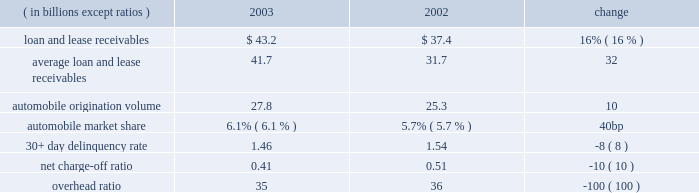Business-related metrics as of or for the year ended december 31 .
Crb is the no .
1 bank in the new york tri-state area and a top five bank in texas ( both ranked by retail deposits ) , providing payment , liquidity , investment , insurance and credit products and services to three primary customer segments : small busi- ness , affluent and retail .
Within these segments , crb serves 326000 small businesses , 433000 affluent consumers and 2.6 million mass-market consumers .
Crb 2019s continued focus on expanding customer relationships resulted in a 14% ( 14 % ) increase in core deposits ( for this purpose , core deposits are total deposits less time deposits ) from december 31 , 2002 , and a 77% ( 77 % ) increase in the cross-sell of chase credit products over 2002 .
In 2003 , mortgage and home equity originations through crb 2019s distribution channels were $ 3.4 billion and $ 4.7 billion , respectively .
Branch-originated credit cards totaled 77000 , contributing to 23% ( 23 % ) of crb customers holding chase credit cards .
Crb is compensated by cfs 2019s credit businesses for the home finance and credit card loans it origi- nates and does not retain these balances .
Chase regional banking while crb continues to position itself for growth , decreased deposit spreads related to the low-rate environment and increased credit costs resulted in an 80% ( 80 % ) decline in crb operating earnings from 2002 .
This decrease was partly offset by an 8% ( 8 % ) increase in total average deposits .
Operating revenue of $ 2.6 billion decreased by 9% ( 9 % ) compared with 2002 .
Net interest income declined by 11% ( 11 % ) to $ 1.7 billion , primarily attributable to the lower interest rate environment .
Noninterest revenue decreased 6% ( 6 % ) to $ 927 million due to lower deposit service fees , decreased debit card fees and one-time gains in 2002 .
Crb 2019s revenue does not include funding profits earned on its deposit base ; these amounts are included in the results of global treasury .
Operating expense of $ 2.4 billion increased by 7% ( 7 % ) from 2002 .
The increase was primarily due to investments in technology within the branch network ; also contributing were higher compensation expenses related to increased staff levels and higher severance costs as a result of continued restructuring .
This increase in operating caf is the largest u.s .
Bank originator of automobile loans and leases , with more than 2.9 million accounts .
In 2003 , caf had a record number of automobile loan and lease originations , growing by 10% ( 10 % ) over 2002 to $ 27.8 billion .
Loan and lease receivables of $ 43.2 billion at december 31 , 2003 , were 16% ( 16 % ) higher than at the prior year-end .
Despite a challenging operating environment reflecting slightly declining new car sales in 2003 and increased competition , caf 2019s market share among automobile finance companies improved to 6.1% ( 6.1 % ) in 2003 from 5.7% ( 5.7 % ) in 2002 .
The increase in market share was the result of strong organic growth and an origination strategy that allies the business with manufac- turers and dealers .
Caf 2019s relationships with several major car manufacturers contributed to 2003 growth , as did caf 2019s dealer relationships , which increased from approximately 12700 dealers in 2002 to approximately 13700 dealers in 2003 .
In 2003 , operating earnings were $ 205 million , 23% ( 23 % ) higher compared with 2002 .
The increase in earnings was driven by continued revenue growth and improved operating efficiency .
In 2003 , caf 2019s operating revenue grew by 23% ( 23 % ) to $ 842 million .
Net interest income grew by 33% ( 33 % ) compared with 2002 .
The increase was driven by strong operating performance due to higher average loans and leases outstanding , reflecting continued strong origination volume and lower funding costs .
Operating expense of $ 292 million increased by 18% ( 18 % ) compared with 2002 .
The increase in expenses was driven by higher average chase auto finance loans outstanding , higher origination volume and higher perform- ance-based incentives .
Caf 2019s overhead ratio improved from 36% ( 36 % ) in 2002 to 35% ( 35 % ) in 2003 , as a result of strong revenue growth , con- tinued productivity gains and disciplined expense management .
Credit costs increased 18% ( 18 % ) to $ 205 million , primarily reflecting a 32% ( 32 % ) increase in average loan and lease receivables .
Credit quality continued to be strong relative to 2002 , as evidenced by a lower net charge-off ratio and 30+ day delinquency rate .
Caf also comprises chase education finance , a top provider of government-guaranteed and private loans for higher education .
Loans are provided through a joint venture with sallie mae , a government-sponsored enterprise and the leader in funding and servicing education loans .
Chase education finance 2019s origination volume totaled $ 2.7 billion , an increase of 4% ( 4 % ) from last year .
Management 2019s discussion and analysis j.p .
Morgan chase & co .
42 j.p .
Morgan chase & co .
/ 2003 annual report .
What was the ratio of the average loan and lease receivables to the automobile origination volume? 
Computations: (41.7 / 27.8)
Answer: 1.5. Business-related metrics as of or for the year ended december 31 .
Crb is the no .
1 bank in the new york tri-state area and a top five bank in texas ( both ranked by retail deposits ) , providing payment , liquidity , investment , insurance and credit products and services to three primary customer segments : small busi- ness , affluent and retail .
Within these segments , crb serves 326000 small businesses , 433000 affluent consumers and 2.6 million mass-market consumers .
Crb 2019s continued focus on expanding customer relationships resulted in a 14% ( 14 % ) increase in core deposits ( for this purpose , core deposits are total deposits less time deposits ) from december 31 , 2002 , and a 77% ( 77 % ) increase in the cross-sell of chase credit products over 2002 .
In 2003 , mortgage and home equity originations through crb 2019s distribution channels were $ 3.4 billion and $ 4.7 billion , respectively .
Branch-originated credit cards totaled 77000 , contributing to 23% ( 23 % ) of crb customers holding chase credit cards .
Crb is compensated by cfs 2019s credit businesses for the home finance and credit card loans it origi- nates and does not retain these balances .
Chase regional banking while crb continues to position itself for growth , decreased deposit spreads related to the low-rate environment and increased credit costs resulted in an 80% ( 80 % ) decline in crb operating earnings from 2002 .
This decrease was partly offset by an 8% ( 8 % ) increase in total average deposits .
Operating revenue of $ 2.6 billion decreased by 9% ( 9 % ) compared with 2002 .
Net interest income declined by 11% ( 11 % ) to $ 1.7 billion , primarily attributable to the lower interest rate environment .
Noninterest revenue decreased 6% ( 6 % ) to $ 927 million due to lower deposit service fees , decreased debit card fees and one-time gains in 2002 .
Crb 2019s revenue does not include funding profits earned on its deposit base ; these amounts are included in the results of global treasury .
Operating expense of $ 2.4 billion increased by 7% ( 7 % ) from 2002 .
The increase was primarily due to investments in technology within the branch network ; also contributing were higher compensation expenses related to increased staff levels and higher severance costs as a result of continued restructuring .
This increase in operating caf is the largest u.s .
Bank originator of automobile loans and leases , with more than 2.9 million accounts .
In 2003 , caf had a record number of automobile loan and lease originations , growing by 10% ( 10 % ) over 2002 to $ 27.8 billion .
Loan and lease receivables of $ 43.2 billion at december 31 , 2003 , were 16% ( 16 % ) higher than at the prior year-end .
Despite a challenging operating environment reflecting slightly declining new car sales in 2003 and increased competition , caf 2019s market share among automobile finance companies improved to 6.1% ( 6.1 % ) in 2003 from 5.7% ( 5.7 % ) in 2002 .
The increase in market share was the result of strong organic growth and an origination strategy that allies the business with manufac- turers and dealers .
Caf 2019s relationships with several major car manufacturers contributed to 2003 growth , as did caf 2019s dealer relationships , which increased from approximately 12700 dealers in 2002 to approximately 13700 dealers in 2003 .
In 2003 , operating earnings were $ 205 million , 23% ( 23 % ) higher compared with 2002 .
The increase in earnings was driven by continued revenue growth and improved operating efficiency .
In 2003 , caf 2019s operating revenue grew by 23% ( 23 % ) to $ 842 million .
Net interest income grew by 33% ( 33 % ) compared with 2002 .
The increase was driven by strong operating performance due to higher average loans and leases outstanding , reflecting continued strong origination volume and lower funding costs .
Operating expense of $ 292 million increased by 18% ( 18 % ) compared with 2002 .
The increase in expenses was driven by higher average chase auto finance loans outstanding , higher origination volume and higher perform- ance-based incentives .
Caf 2019s overhead ratio improved from 36% ( 36 % ) in 2002 to 35% ( 35 % ) in 2003 , as a result of strong revenue growth , con- tinued productivity gains and disciplined expense management .
Credit costs increased 18% ( 18 % ) to $ 205 million , primarily reflecting a 32% ( 32 % ) increase in average loan and lease receivables .
Credit quality continued to be strong relative to 2002 , as evidenced by a lower net charge-off ratio and 30+ day delinquency rate .
Caf also comprises chase education finance , a top provider of government-guaranteed and private loans for higher education .
Loans are provided through a joint venture with sallie mae , a government-sponsored enterprise and the leader in funding and servicing education loans .
Chase education finance 2019s origination volume totaled $ 2.7 billion , an increase of 4% ( 4 % ) from last year .
Management 2019s discussion and analysis j.p .
Morgan chase & co .
42 j.p .
Morgan chase & co .
/ 2003 annual report .
What was the operating revenue in 2002? 
Computations: (205 * (100 - 23%))
Answer: 20452.85. Business-related metrics as of or for the year ended december 31 .
Crb is the no .
1 bank in the new york tri-state area and a top five bank in texas ( both ranked by retail deposits ) , providing payment , liquidity , investment , insurance and credit products and services to three primary customer segments : small busi- ness , affluent and retail .
Within these segments , crb serves 326000 small businesses , 433000 affluent consumers and 2.6 million mass-market consumers .
Crb 2019s continued focus on expanding customer relationships resulted in a 14% ( 14 % ) increase in core deposits ( for this purpose , core deposits are total deposits less time deposits ) from december 31 , 2002 , and a 77% ( 77 % ) increase in the cross-sell of chase credit products over 2002 .
In 2003 , mortgage and home equity originations through crb 2019s distribution channels were $ 3.4 billion and $ 4.7 billion , respectively .
Branch-originated credit cards totaled 77000 , contributing to 23% ( 23 % ) of crb customers holding chase credit cards .
Crb is compensated by cfs 2019s credit businesses for the home finance and credit card loans it origi- nates and does not retain these balances .
Chase regional banking while crb continues to position itself for growth , decreased deposit spreads related to the low-rate environment and increased credit costs resulted in an 80% ( 80 % ) decline in crb operating earnings from 2002 .
This decrease was partly offset by an 8% ( 8 % ) increase in total average deposits .
Operating revenue of $ 2.6 billion decreased by 9% ( 9 % ) compared with 2002 .
Net interest income declined by 11% ( 11 % ) to $ 1.7 billion , primarily attributable to the lower interest rate environment .
Noninterest revenue decreased 6% ( 6 % ) to $ 927 million due to lower deposit service fees , decreased debit card fees and one-time gains in 2002 .
Crb 2019s revenue does not include funding profits earned on its deposit base ; these amounts are included in the results of global treasury .
Operating expense of $ 2.4 billion increased by 7% ( 7 % ) from 2002 .
The increase was primarily due to investments in technology within the branch network ; also contributing were higher compensation expenses related to increased staff levels and higher severance costs as a result of continued restructuring .
This increase in operating caf is the largest u.s .
Bank originator of automobile loans and leases , with more than 2.9 million accounts .
In 2003 , caf had a record number of automobile loan and lease originations , growing by 10% ( 10 % ) over 2002 to $ 27.8 billion .
Loan and lease receivables of $ 43.2 billion at december 31 , 2003 , were 16% ( 16 % ) higher than at the prior year-end .
Despite a challenging operating environment reflecting slightly declining new car sales in 2003 and increased competition , caf 2019s market share among automobile finance companies improved to 6.1% ( 6.1 % ) in 2003 from 5.7% ( 5.7 % ) in 2002 .
The increase in market share was the result of strong organic growth and an origination strategy that allies the business with manufac- turers and dealers .
Caf 2019s relationships with several major car manufacturers contributed to 2003 growth , as did caf 2019s dealer relationships , which increased from approximately 12700 dealers in 2002 to approximately 13700 dealers in 2003 .
In 2003 , operating earnings were $ 205 million , 23% ( 23 % ) higher compared with 2002 .
The increase in earnings was driven by continued revenue growth and improved operating efficiency .
In 2003 , caf 2019s operating revenue grew by 23% ( 23 % ) to $ 842 million .
Net interest income grew by 33% ( 33 % ) compared with 2002 .
The increase was driven by strong operating performance due to higher average loans and leases outstanding , reflecting continued strong origination volume and lower funding costs .
Operating expense of $ 292 million increased by 18% ( 18 % ) compared with 2002 .
The increase in expenses was driven by higher average chase auto finance loans outstanding , higher origination volume and higher perform- ance-based incentives .
Caf 2019s overhead ratio improved from 36% ( 36 % ) in 2002 to 35% ( 35 % ) in 2003 , as a result of strong revenue growth , con- tinued productivity gains and disciplined expense management .
Credit costs increased 18% ( 18 % ) to $ 205 million , primarily reflecting a 32% ( 32 % ) increase in average loan and lease receivables .
Credit quality continued to be strong relative to 2002 , as evidenced by a lower net charge-off ratio and 30+ day delinquency rate .
Caf also comprises chase education finance , a top provider of government-guaranteed and private loans for higher education .
Loans are provided through a joint venture with sallie mae , a government-sponsored enterprise and the leader in funding and servicing education loans .
Chase education finance 2019s origination volume totaled $ 2.7 billion , an increase of 4% ( 4 % ) from last year .
Management 2019s discussion and analysis j.p .
Morgan chase & co .
42 j.p .
Morgan chase & co .
/ 2003 annual report .
What was the 2003 improvement in the 30+ day delinquency rate , ( us$ b ) ? 
Computations: ((8 / 100) * 1.54)
Answer: 0.1232. Business-related metrics as of or for the year ended december 31 .
Crb is the no .
1 bank in the new york tri-state area and a top five bank in texas ( both ranked by retail deposits ) , providing payment , liquidity , investment , insurance and credit products and services to three primary customer segments : small busi- ness , affluent and retail .
Within these segments , crb serves 326000 small businesses , 433000 affluent consumers and 2.6 million mass-market consumers .
Crb 2019s continued focus on expanding customer relationships resulted in a 14% ( 14 % ) increase in core deposits ( for this purpose , core deposits are total deposits less time deposits ) from december 31 , 2002 , and a 77% ( 77 % ) increase in the cross-sell of chase credit products over 2002 .
In 2003 , mortgage and home equity originations through crb 2019s distribution channels were $ 3.4 billion and $ 4.7 billion , respectively .
Branch-originated credit cards totaled 77000 , contributing to 23% ( 23 % ) of crb customers holding chase credit cards .
Crb is compensated by cfs 2019s credit businesses for the home finance and credit card loans it origi- nates and does not retain these balances .
Chase regional banking while crb continues to position itself for growth , decreased deposit spreads related to the low-rate environment and increased credit costs resulted in an 80% ( 80 % ) decline in crb operating earnings from 2002 .
This decrease was partly offset by an 8% ( 8 % ) increase in total average deposits .
Operating revenue of $ 2.6 billion decreased by 9% ( 9 % ) compared with 2002 .
Net interest income declined by 11% ( 11 % ) to $ 1.7 billion , primarily attributable to the lower interest rate environment .
Noninterest revenue decreased 6% ( 6 % ) to $ 927 million due to lower deposit service fees , decreased debit card fees and one-time gains in 2002 .
Crb 2019s revenue does not include funding profits earned on its deposit base ; these amounts are included in the results of global treasury .
Operating expense of $ 2.4 billion increased by 7% ( 7 % ) from 2002 .
The increase was primarily due to investments in technology within the branch network ; also contributing were higher compensation expenses related to increased staff levels and higher severance costs as a result of continued restructuring .
This increase in operating caf is the largest u.s .
Bank originator of automobile loans and leases , with more than 2.9 million accounts .
In 2003 , caf had a record number of automobile loan and lease originations , growing by 10% ( 10 % ) over 2002 to $ 27.8 billion .
Loan and lease receivables of $ 43.2 billion at december 31 , 2003 , were 16% ( 16 % ) higher than at the prior year-end .
Despite a challenging operating environment reflecting slightly declining new car sales in 2003 and increased competition , caf 2019s market share among automobile finance companies improved to 6.1% ( 6.1 % ) in 2003 from 5.7% ( 5.7 % ) in 2002 .
The increase in market share was the result of strong organic growth and an origination strategy that allies the business with manufac- turers and dealers .
Caf 2019s relationships with several major car manufacturers contributed to 2003 growth , as did caf 2019s dealer relationships , which increased from approximately 12700 dealers in 2002 to approximately 13700 dealers in 2003 .
In 2003 , operating earnings were $ 205 million , 23% ( 23 % ) higher compared with 2002 .
The increase in earnings was driven by continued revenue growth and improved operating efficiency .
In 2003 , caf 2019s operating revenue grew by 23% ( 23 % ) to $ 842 million .
Net interest income grew by 33% ( 33 % ) compared with 2002 .
The increase was driven by strong operating performance due to higher average loans and leases outstanding , reflecting continued strong origination volume and lower funding costs .
Operating expense of $ 292 million increased by 18% ( 18 % ) compared with 2002 .
The increase in expenses was driven by higher average chase auto finance loans outstanding , higher origination volume and higher perform- ance-based incentives .
Caf 2019s overhead ratio improved from 36% ( 36 % ) in 2002 to 35% ( 35 % ) in 2003 , as a result of strong revenue growth , con- tinued productivity gains and disciplined expense management .
Credit costs increased 18% ( 18 % ) to $ 205 million , primarily reflecting a 32% ( 32 % ) increase in average loan and lease receivables .
Credit quality continued to be strong relative to 2002 , as evidenced by a lower net charge-off ratio and 30+ day delinquency rate .
Caf also comprises chase education finance , a top provider of government-guaranteed and private loans for higher education .
Loans are provided through a joint venture with sallie mae , a government-sponsored enterprise and the leader in funding and servicing education loans .
Chase education finance 2019s origination volume totaled $ 2.7 billion , an increase of 4% ( 4 % ) from last year .
Management 2019s discussion and analysis j.p .
Morgan chase & co .
42 j.p .
Morgan chase & co .
/ 2003 annual report .
What was the decline from 2002 to 2003 in interest income , in us$ b? 
Computations: ((1.7 / (1 - 11%)) - 1.7)
Answer: 0.21011. 